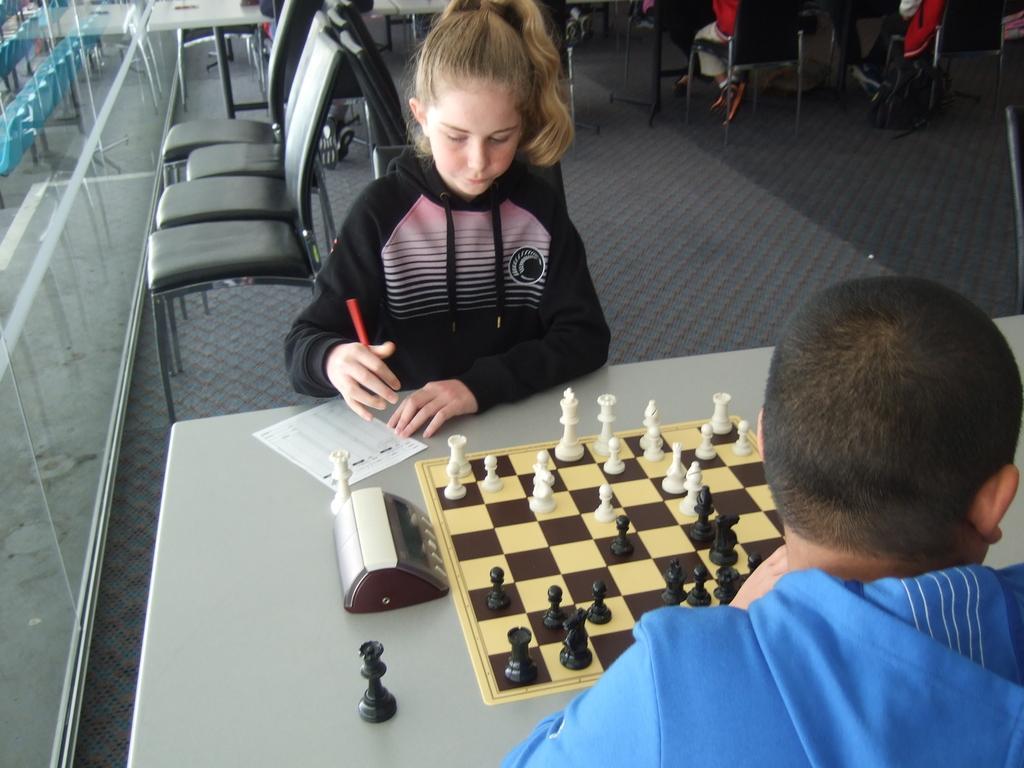How would you summarize this image in a sentence or two? We can able to see chairs. This girl and this man are sitting on a chair. In-front of this person there is a table, on a table there is a paper, chess board coins and board. This girl is holding a pen. Far we can able to see persons sitting on a chair. Beside this chair there is a bag. 